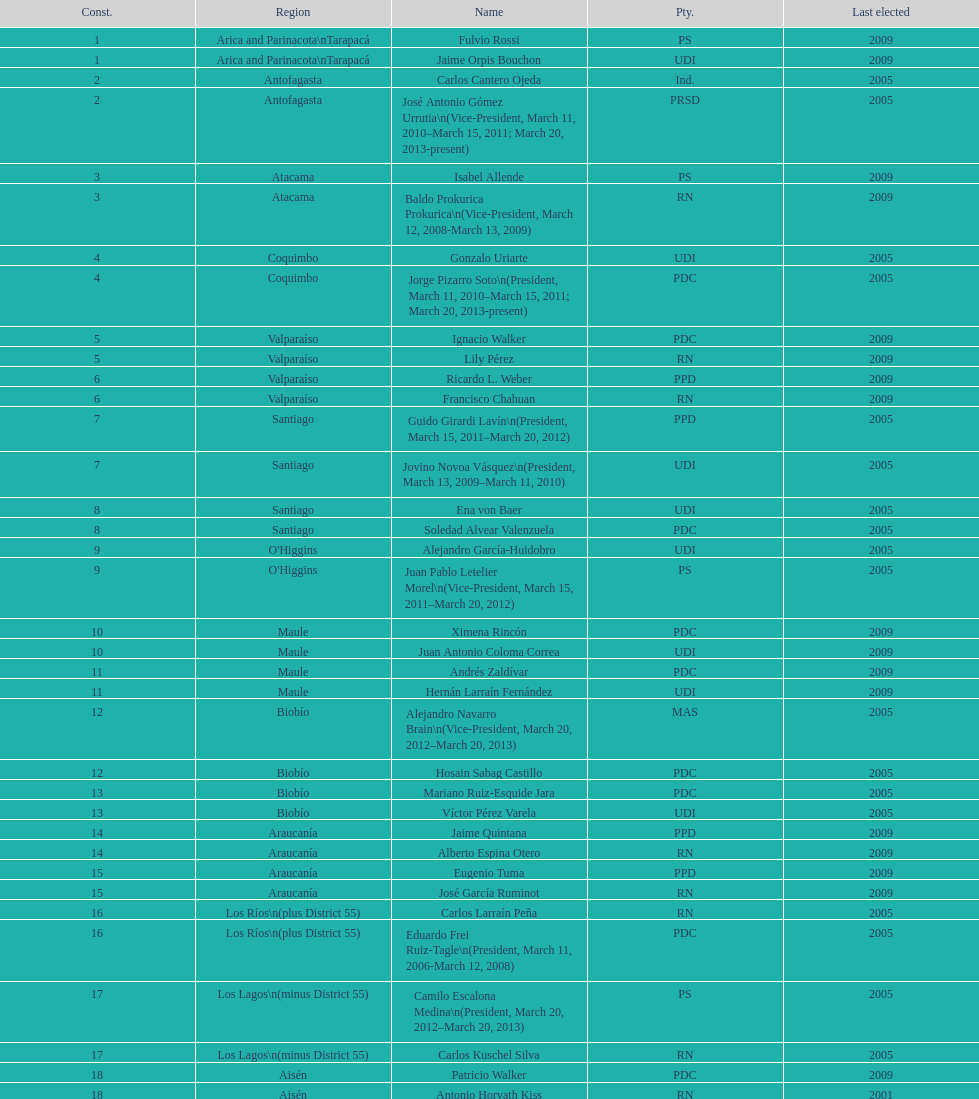How many total consituency are listed in the table? 19. 